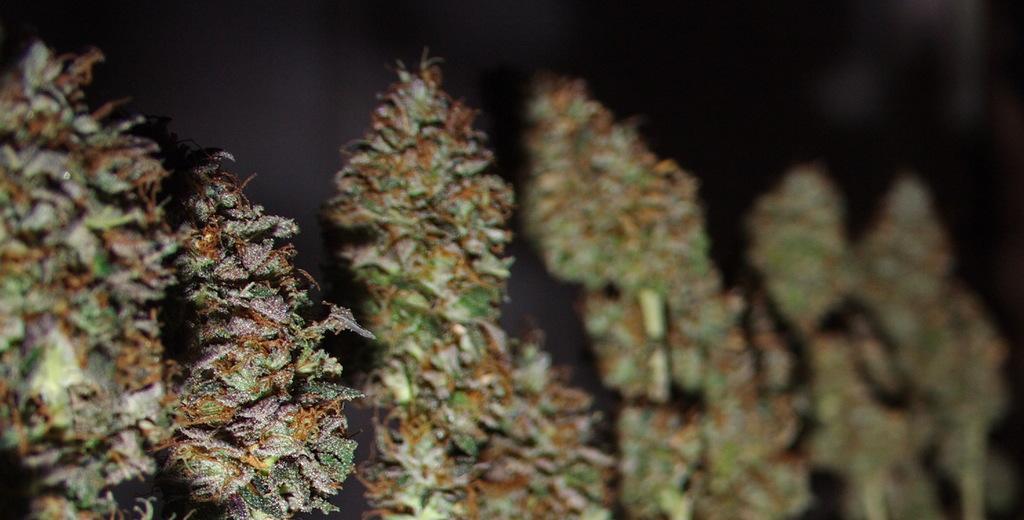Can you describe this image briefly? By seeing this image we can say it is a macro photography of plants. On the right side of the image is in a blur. 